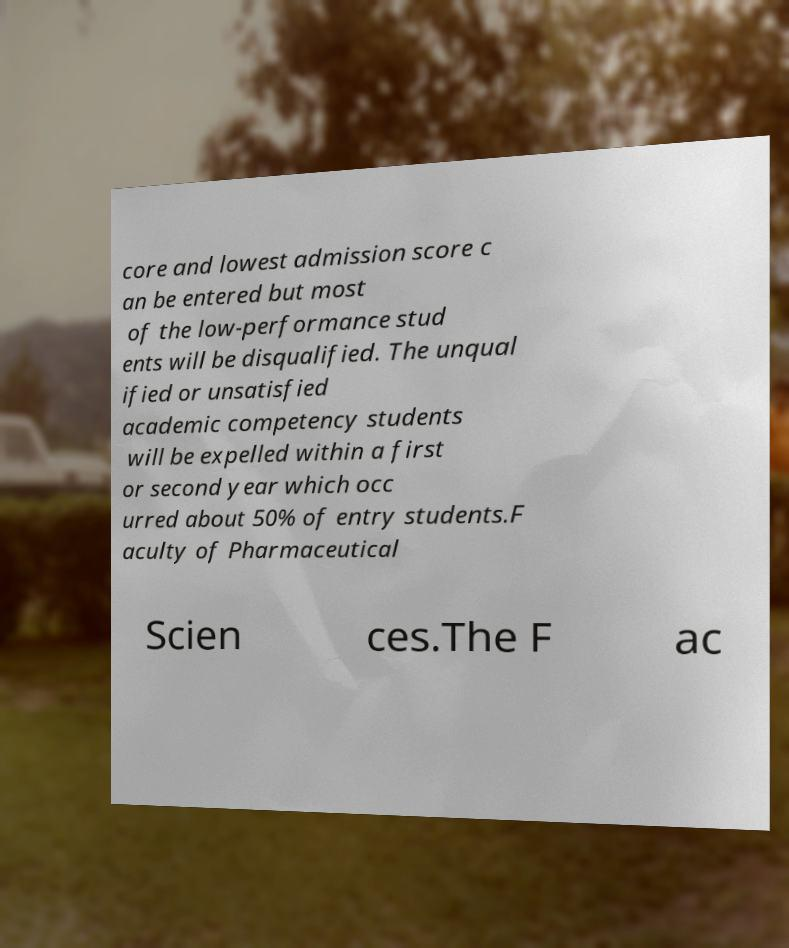Please identify and transcribe the text found in this image. core and lowest admission score c an be entered but most of the low-performance stud ents will be disqualified. The unqual ified or unsatisfied academic competency students will be expelled within a first or second year which occ urred about 50% of entry students.F aculty of Pharmaceutical Scien ces.The F ac 